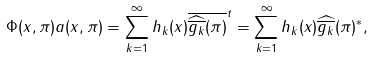<formula> <loc_0><loc_0><loc_500><loc_500>\Phi ( x , \pi ) a ( x , \pi ) = \sum _ { k = 1 } ^ { \infty } h _ { k } ( x ) \overline { \widehat { \overline { g _ { k } } } ( \pi ) } ^ { t } = \sum _ { k = 1 } ^ { \infty } h _ { k } ( x ) \widehat { \overline { g _ { k } } } ( \pi ) ^ { * } ,</formula> 